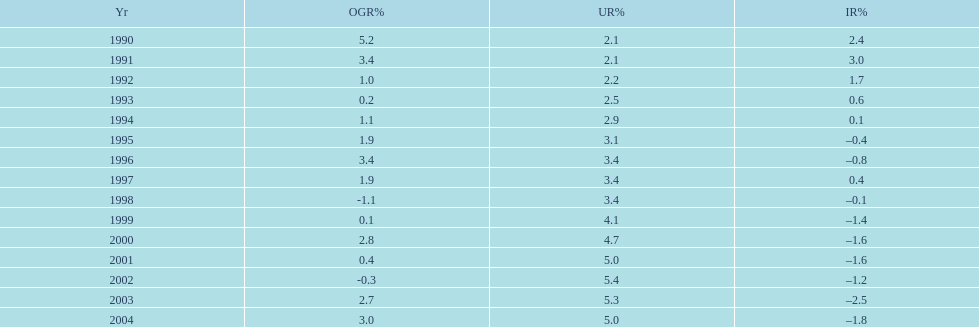What year saw the highest output growth rate in japan between the years 1990 and 2004? 1990. 